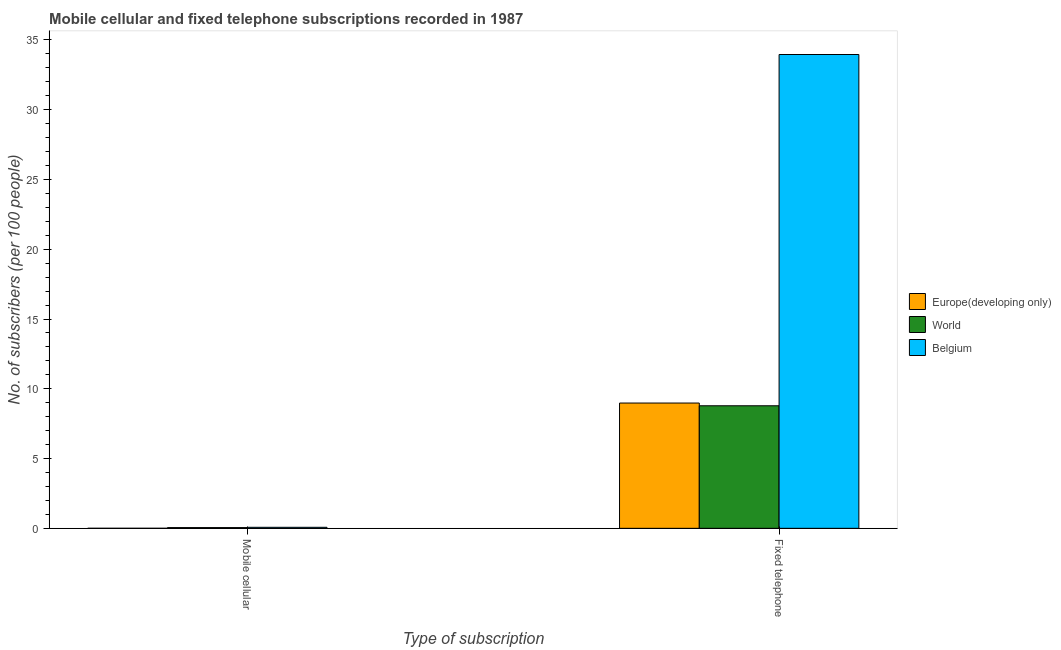How many bars are there on the 1st tick from the left?
Give a very brief answer. 3. What is the label of the 2nd group of bars from the left?
Offer a terse response. Fixed telephone. What is the number of mobile cellular subscribers in Europe(developing only)?
Ensure brevity in your answer.  0. Across all countries, what is the maximum number of mobile cellular subscribers?
Your answer should be compact. 0.07. Across all countries, what is the minimum number of fixed telephone subscribers?
Ensure brevity in your answer.  8.78. In which country was the number of mobile cellular subscribers maximum?
Your answer should be very brief. Belgium. In which country was the number of fixed telephone subscribers minimum?
Keep it short and to the point. World. What is the total number of mobile cellular subscribers in the graph?
Offer a very short reply. 0.13. What is the difference between the number of mobile cellular subscribers in World and that in Europe(developing only)?
Ensure brevity in your answer.  0.05. What is the difference between the number of mobile cellular subscribers in Belgium and the number of fixed telephone subscribers in Europe(developing only)?
Your answer should be very brief. -8.91. What is the average number of fixed telephone subscribers per country?
Your response must be concise. 17.24. What is the difference between the number of mobile cellular subscribers and number of fixed telephone subscribers in World?
Give a very brief answer. -8.73. What is the ratio of the number of fixed telephone subscribers in Europe(developing only) to that in World?
Your answer should be compact. 1.02. In how many countries, is the number of fixed telephone subscribers greater than the average number of fixed telephone subscribers taken over all countries?
Your answer should be compact. 1. What does the 1st bar from the left in Mobile cellular represents?
Offer a terse response. Europe(developing only). How many bars are there?
Provide a succinct answer. 6. Are all the bars in the graph horizontal?
Ensure brevity in your answer.  No. Are the values on the major ticks of Y-axis written in scientific E-notation?
Your answer should be compact. No. Does the graph contain any zero values?
Your response must be concise. No. How are the legend labels stacked?
Give a very brief answer. Vertical. What is the title of the graph?
Your answer should be compact. Mobile cellular and fixed telephone subscriptions recorded in 1987. Does "Low income" appear as one of the legend labels in the graph?
Give a very brief answer. No. What is the label or title of the X-axis?
Ensure brevity in your answer.  Type of subscription. What is the label or title of the Y-axis?
Your response must be concise. No. of subscribers (per 100 people). What is the No. of subscribers (per 100 people) of Europe(developing only) in Mobile cellular?
Your answer should be very brief. 0. What is the No. of subscribers (per 100 people) of World in Mobile cellular?
Give a very brief answer. 0.05. What is the No. of subscribers (per 100 people) of Belgium in Mobile cellular?
Give a very brief answer. 0.07. What is the No. of subscribers (per 100 people) in Europe(developing only) in Fixed telephone?
Offer a very short reply. 8.98. What is the No. of subscribers (per 100 people) of World in Fixed telephone?
Your answer should be compact. 8.78. What is the No. of subscribers (per 100 people) in Belgium in Fixed telephone?
Your answer should be compact. 33.96. Across all Type of subscription, what is the maximum No. of subscribers (per 100 people) in Europe(developing only)?
Give a very brief answer. 8.98. Across all Type of subscription, what is the maximum No. of subscribers (per 100 people) of World?
Your response must be concise. 8.78. Across all Type of subscription, what is the maximum No. of subscribers (per 100 people) of Belgium?
Your response must be concise. 33.96. Across all Type of subscription, what is the minimum No. of subscribers (per 100 people) of Europe(developing only)?
Your answer should be compact. 0. Across all Type of subscription, what is the minimum No. of subscribers (per 100 people) of World?
Provide a succinct answer. 0.05. Across all Type of subscription, what is the minimum No. of subscribers (per 100 people) in Belgium?
Give a very brief answer. 0.07. What is the total No. of subscribers (per 100 people) of Europe(developing only) in the graph?
Provide a succinct answer. 8.98. What is the total No. of subscribers (per 100 people) in World in the graph?
Give a very brief answer. 8.83. What is the total No. of subscribers (per 100 people) in Belgium in the graph?
Your response must be concise. 34.03. What is the difference between the No. of subscribers (per 100 people) in Europe(developing only) in Mobile cellular and that in Fixed telephone?
Your answer should be very brief. -8.98. What is the difference between the No. of subscribers (per 100 people) of World in Mobile cellular and that in Fixed telephone?
Make the answer very short. -8.73. What is the difference between the No. of subscribers (per 100 people) of Belgium in Mobile cellular and that in Fixed telephone?
Give a very brief answer. -33.88. What is the difference between the No. of subscribers (per 100 people) of Europe(developing only) in Mobile cellular and the No. of subscribers (per 100 people) of World in Fixed telephone?
Offer a terse response. -8.78. What is the difference between the No. of subscribers (per 100 people) of Europe(developing only) in Mobile cellular and the No. of subscribers (per 100 people) of Belgium in Fixed telephone?
Your answer should be very brief. -33.95. What is the difference between the No. of subscribers (per 100 people) in World in Mobile cellular and the No. of subscribers (per 100 people) in Belgium in Fixed telephone?
Offer a very short reply. -33.91. What is the average No. of subscribers (per 100 people) of Europe(developing only) per Type of subscription?
Your answer should be very brief. 4.49. What is the average No. of subscribers (per 100 people) of World per Type of subscription?
Offer a terse response. 4.42. What is the average No. of subscribers (per 100 people) of Belgium per Type of subscription?
Your answer should be compact. 17.01. What is the difference between the No. of subscribers (per 100 people) in Europe(developing only) and No. of subscribers (per 100 people) in World in Mobile cellular?
Ensure brevity in your answer.  -0.05. What is the difference between the No. of subscribers (per 100 people) of Europe(developing only) and No. of subscribers (per 100 people) of Belgium in Mobile cellular?
Offer a very short reply. -0.07. What is the difference between the No. of subscribers (per 100 people) in World and No. of subscribers (per 100 people) in Belgium in Mobile cellular?
Provide a succinct answer. -0.02. What is the difference between the No. of subscribers (per 100 people) in Europe(developing only) and No. of subscribers (per 100 people) in World in Fixed telephone?
Your answer should be compact. 0.2. What is the difference between the No. of subscribers (per 100 people) in Europe(developing only) and No. of subscribers (per 100 people) in Belgium in Fixed telephone?
Your answer should be compact. -24.98. What is the difference between the No. of subscribers (per 100 people) in World and No. of subscribers (per 100 people) in Belgium in Fixed telephone?
Offer a very short reply. -25.17. What is the ratio of the No. of subscribers (per 100 people) in Europe(developing only) in Mobile cellular to that in Fixed telephone?
Keep it short and to the point. 0. What is the ratio of the No. of subscribers (per 100 people) in World in Mobile cellular to that in Fixed telephone?
Give a very brief answer. 0.01. What is the ratio of the No. of subscribers (per 100 people) in Belgium in Mobile cellular to that in Fixed telephone?
Give a very brief answer. 0. What is the difference between the highest and the second highest No. of subscribers (per 100 people) of Europe(developing only)?
Give a very brief answer. 8.98. What is the difference between the highest and the second highest No. of subscribers (per 100 people) in World?
Keep it short and to the point. 8.73. What is the difference between the highest and the second highest No. of subscribers (per 100 people) of Belgium?
Make the answer very short. 33.88. What is the difference between the highest and the lowest No. of subscribers (per 100 people) in Europe(developing only)?
Make the answer very short. 8.98. What is the difference between the highest and the lowest No. of subscribers (per 100 people) in World?
Offer a very short reply. 8.73. What is the difference between the highest and the lowest No. of subscribers (per 100 people) of Belgium?
Provide a short and direct response. 33.88. 